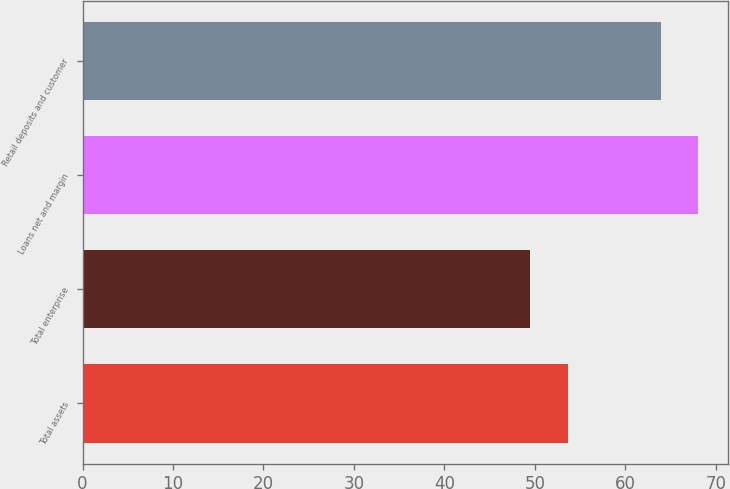<chart> <loc_0><loc_0><loc_500><loc_500><bar_chart><fcel>Total assets<fcel>Total enterprise<fcel>Loans net and margin<fcel>Retail deposits and customer<nl><fcel>53.7<fcel>49.5<fcel>68<fcel>64<nl></chart> 